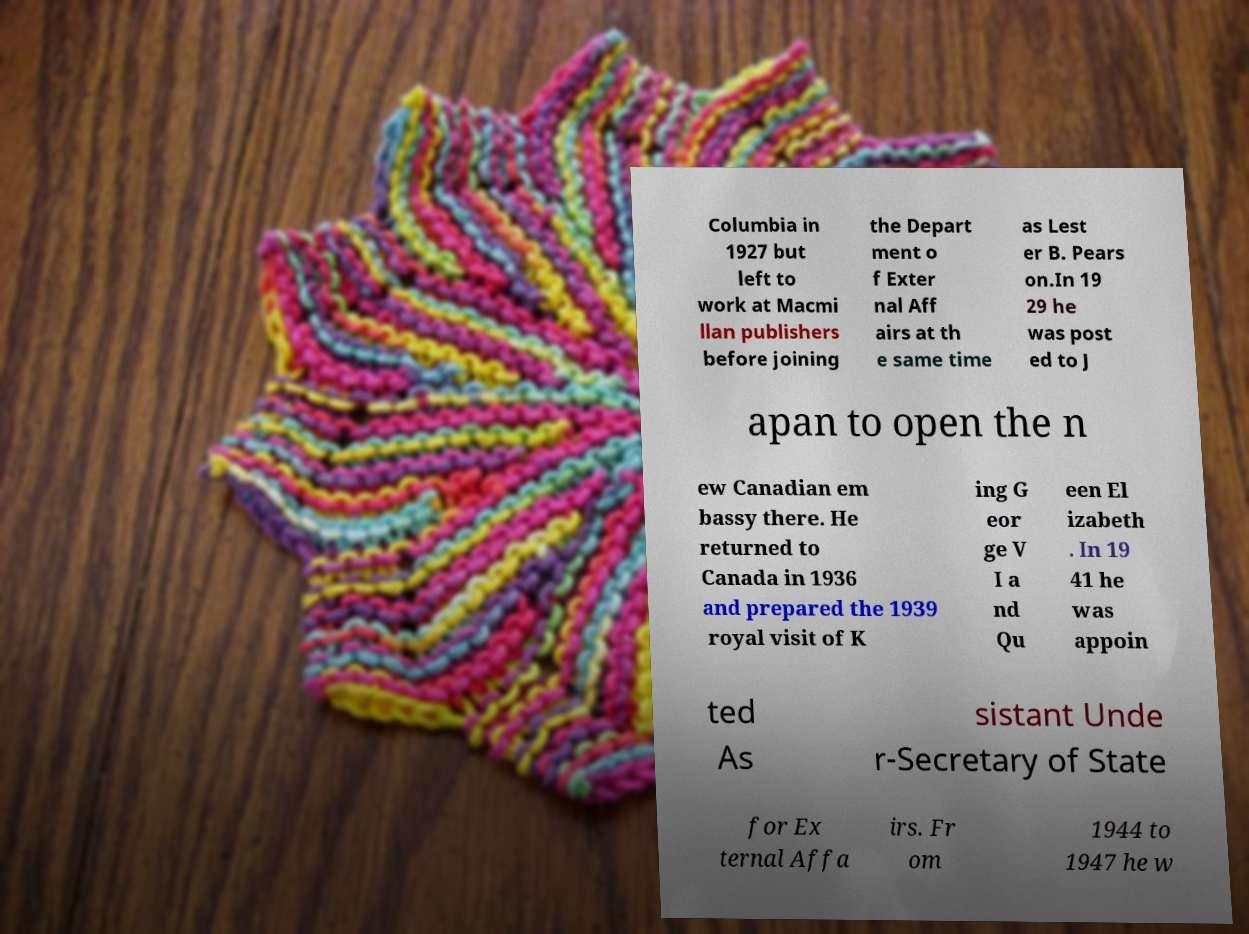Could you extract and type out the text from this image? Columbia in 1927 but left to work at Macmi llan publishers before joining the Depart ment o f Exter nal Aff airs at th e same time as Lest er B. Pears on.In 19 29 he was post ed to J apan to open the n ew Canadian em bassy there. He returned to Canada in 1936 and prepared the 1939 royal visit of K ing G eor ge V I a nd Qu een El izabeth . In 19 41 he was appoin ted As sistant Unde r-Secretary of State for Ex ternal Affa irs. Fr om 1944 to 1947 he w 